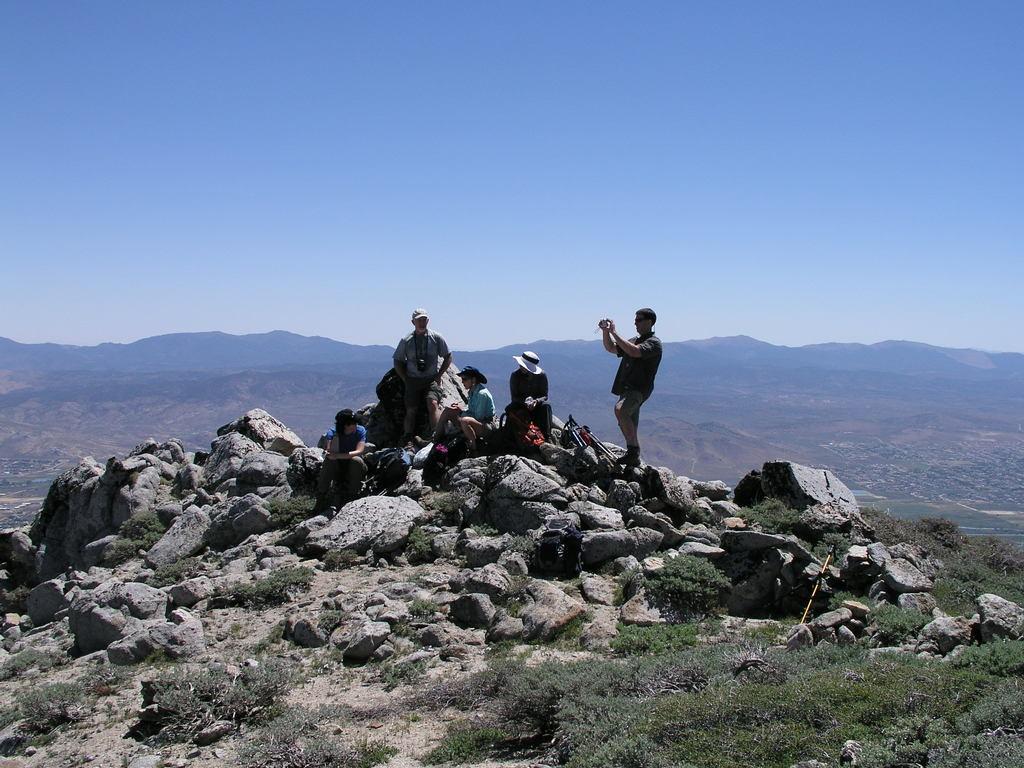Could you give a brief overview of what you see in this image? In this image there are people sitting on rocks and few are standing, in the background there are mountains and the sky, on the bottom right there is grass. 